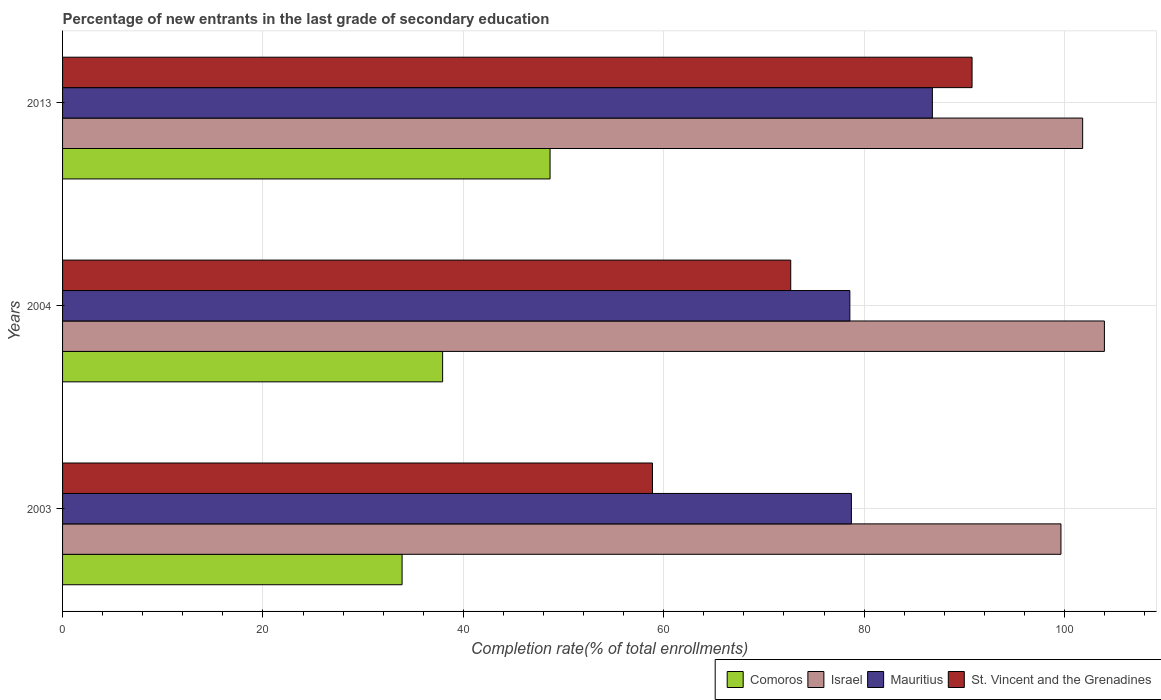Are the number of bars per tick equal to the number of legend labels?
Offer a terse response. Yes. What is the percentage of new entrants in Mauritius in 2003?
Ensure brevity in your answer.  78.73. Across all years, what is the maximum percentage of new entrants in Mauritius?
Offer a terse response. 86.81. Across all years, what is the minimum percentage of new entrants in Mauritius?
Offer a terse response. 78.57. In which year was the percentage of new entrants in St. Vincent and the Grenadines minimum?
Keep it short and to the point. 2003. What is the total percentage of new entrants in Israel in the graph?
Give a very brief answer. 305.43. What is the difference between the percentage of new entrants in Mauritius in 2004 and that in 2013?
Your answer should be very brief. -8.24. What is the difference between the percentage of new entrants in Israel in 2004 and the percentage of new entrants in St. Vincent and the Grenadines in 2003?
Offer a very short reply. 45.1. What is the average percentage of new entrants in St. Vincent and the Grenadines per year?
Your answer should be very brief. 74.11. In the year 2003, what is the difference between the percentage of new entrants in St. Vincent and the Grenadines and percentage of new entrants in Mauritius?
Offer a very short reply. -19.85. What is the ratio of the percentage of new entrants in Mauritius in 2003 to that in 2013?
Give a very brief answer. 0.91. What is the difference between the highest and the second highest percentage of new entrants in Comoros?
Ensure brevity in your answer.  10.72. What is the difference between the highest and the lowest percentage of new entrants in St. Vincent and the Grenadines?
Offer a very short reply. 31.89. In how many years, is the percentage of new entrants in Comoros greater than the average percentage of new entrants in Comoros taken over all years?
Offer a terse response. 1. What does the 2nd bar from the top in 2004 represents?
Offer a terse response. Mauritius. What does the 4th bar from the bottom in 2004 represents?
Give a very brief answer. St. Vincent and the Grenadines. How many bars are there?
Offer a terse response. 12. What is the difference between two consecutive major ticks on the X-axis?
Offer a very short reply. 20. Are the values on the major ticks of X-axis written in scientific E-notation?
Your response must be concise. No. Does the graph contain grids?
Offer a very short reply. Yes. How many legend labels are there?
Keep it short and to the point. 4. What is the title of the graph?
Give a very brief answer. Percentage of new entrants in the last grade of secondary education. What is the label or title of the X-axis?
Offer a very short reply. Completion rate(% of total enrollments). What is the label or title of the Y-axis?
Give a very brief answer. Years. What is the Completion rate(% of total enrollments) in Comoros in 2003?
Make the answer very short. 33.89. What is the Completion rate(% of total enrollments) in Israel in 2003?
Your answer should be very brief. 99.64. What is the Completion rate(% of total enrollments) in Mauritius in 2003?
Provide a short and direct response. 78.73. What is the Completion rate(% of total enrollments) in St. Vincent and the Grenadines in 2003?
Provide a succinct answer. 58.88. What is the Completion rate(% of total enrollments) of Comoros in 2004?
Your answer should be very brief. 37.93. What is the Completion rate(% of total enrollments) in Israel in 2004?
Your answer should be very brief. 103.98. What is the Completion rate(% of total enrollments) of Mauritius in 2004?
Your answer should be very brief. 78.57. What is the Completion rate(% of total enrollments) of St. Vincent and the Grenadines in 2004?
Offer a terse response. 72.67. What is the Completion rate(% of total enrollments) in Comoros in 2013?
Your response must be concise. 48.65. What is the Completion rate(% of total enrollments) of Israel in 2013?
Give a very brief answer. 101.81. What is the Completion rate(% of total enrollments) of Mauritius in 2013?
Offer a terse response. 86.81. What is the Completion rate(% of total enrollments) in St. Vincent and the Grenadines in 2013?
Offer a very short reply. 90.77. Across all years, what is the maximum Completion rate(% of total enrollments) in Comoros?
Keep it short and to the point. 48.65. Across all years, what is the maximum Completion rate(% of total enrollments) in Israel?
Your response must be concise. 103.98. Across all years, what is the maximum Completion rate(% of total enrollments) in Mauritius?
Give a very brief answer. 86.81. Across all years, what is the maximum Completion rate(% of total enrollments) in St. Vincent and the Grenadines?
Your answer should be compact. 90.77. Across all years, what is the minimum Completion rate(% of total enrollments) in Comoros?
Provide a succinct answer. 33.89. Across all years, what is the minimum Completion rate(% of total enrollments) of Israel?
Offer a terse response. 99.64. Across all years, what is the minimum Completion rate(% of total enrollments) in Mauritius?
Your response must be concise. 78.57. Across all years, what is the minimum Completion rate(% of total enrollments) of St. Vincent and the Grenadines?
Provide a short and direct response. 58.88. What is the total Completion rate(% of total enrollments) in Comoros in the graph?
Ensure brevity in your answer.  120.47. What is the total Completion rate(% of total enrollments) of Israel in the graph?
Your answer should be compact. 305.43. What is the total Completion rate(% of total enrollments) in Mauritius in the graph?
Give a very brief answer. 244.11. What is the total Completion rate(% of total enrollments) of St. Vincent and the Grenadines in the graph?
Make the answer very short. 222.32. What is the difference between the Completion rate(% of total enrollments) of Comoros in 2003 and that in 2004?
Keep it short and to the point. -4.05. What is the difference between the Completion rate(% of total enrollments) in Israel in 2003 and that in 2004?
Ensure brevity in your answer.  -4.34. What is the difference between the Completion rate(% of total enrollments) of Mauritius in 2003 and that in 2004?
Offer a terse response. 0.15. What is the difference between the Completion rate(% of total enrollments) of St. Vincent and the Grenadines in 2003 and that in 2004?
Make the answer very short. -13.8. What is the difference between the Completion rate(% of total enrollments) of Comoros in 2003 and that in 2013?
Offer a very short reply. -14.77. What is the difference between the Completion rate(% of total enrollments) of Israel in 2003 and that in 2013?
Make the answer very short. -2.17. What is the difference between the Completion rate(% of total enrollments) of Mauritius in 2003 and that in 2013?
Your answer should be compact. -8.08. What is the difference between the Completion rate(% of total enrollments) of St. Vincent and the Grenadines in 2003 and that in 2013?
Offer a terse response. -31.89. What is the difference between the Completion rate(% of total enrollments) of Comoros in 2004 and that in 2013?
Give a very brief answer. -10.72. What is the difference between the Completion rate(% of total enrollments) in Israel in 2004 and that in 2013?
Your response must be concise. 2.17. What is the difference between the Completion rate(% of total enrollments) in Mauritius in 2004 and that in 2013?
Offer a very short reply. -8.24. What is the difference between the Completion rate(% of total enrollments) in St. Vincent and the Grenadines in 2004 and that in 2013?
Keep it short and to the point. -18.1. What is the difference between the Completion rate(% of total enrollments) of Comoros in 2003 and the Completion rate(% of total enrollments) of Israel in 2004?
Your response must be concise. -70.09. What is the difference between the Completion rate(% of total enrollments) of Comoros in 2003 and the Completion rate(% of total enrollments) of Mauritius in 2004?
Your answer should be compact. -44.69. What is the difference between the Completion rate(% of total enrollments) of Comoros in 2003 and the Completion rate(% of total enrollments) of St. Vincent and the Grenadines in 2004?
Keep it short and to the point. -38.79. What is the difference between the Completion rate(% of total enrollments) in Israel in 2003 and the Completion rate(% of total enrollments) in Mauritius in 2004?
Offer a very short reply. 21.07. What is the difference between the Completion rate(% of total enrollments) in Israel in 2003 and the Completion rate(% of total enrollments) in St. Vincent and the Grenadines in 2004?
Your answer should be compact. 26.97. What is the difference between the Completion rate(% of total enrollments) in Mauritius in 2003 and the Completion rate(% of total enrollments) in St. Vincent and the Grenadines in 2004?
Give a very brief answer. 6.05. What is the difference between the Completion rate(% of total enrollments) in Comoros in 2003 and the Completion rate(% of total enrollments) in Israel in 2013?
Provide a succinct answer. -67.92. What is the difference between the Completion rate(% of total enrollments) in Comoros in 2003 and the Completion rate(% of total enrollments) in Mauritius in 2013?
Your answer should be very brief. -52.92. What is the difference between the Completion rate(% of total enrollments) of Comoros in 2003 and the Completion rate(% of total enrollments) of St. Vincent and the Grenadines in 2013?
Your response must be concise. -56.89. What is the difference between the Completion rate(% of total enrollments) in Israel in 2003 and the Completion rate(% of total enrollments) in Mauritius in 2013?
Make the answer very short. 12.83. What is the difference between the Completion rate(% of total enrollments) in Israel in 2003 and the Completion rate(% of total enrollments) in St. Vincent and the Grenadines in 2013?
Provide a succinct answer. 8.87. What is the difference between the Completion rate(% of total enrollments) in Mauritius in 2003 and the Completion rate(% of total enrollments) in St. Vincent and the Grenadines in 2013?
Give a very brief answer. -12.04. What is the difference between the Completion rate(% of total enrollments) of Comoros in 2004 and the Completion rate(% of total enrollments) of Israel in 2013?
Ensure brevity in your answer.  -63.88. What is the difference between the Completion rate(% of total enrollments) in Comoros in 2004 and the Completion rate(% of total enrollments) in Mauritius in 2013?
Make the answer very short. -48.88. What is the difference between the Completion rate(% of total enrollments) of Comoros in 2004 and the Completion rate(% of total enrollments) of St. Vincent and the Grenadines in 2013?
Keep it short and to the point. -52.84. What is the difference between the Completion rate(% of total enrollments) in Israel in 2004 and the Completion rate(% of total enrollments) in Mauritius in 2013?
Your answer should be very brief. 17.17. What is the difference between the Completion rate(% of total enrollments) in Israel in 2004 and the Completion rate(% of total enrollments) in St. Vincent and the Grenadines in 2013?
Ensure brevity in your answer.  13.21. What is the difference between the Completion rate(% of total enrollments) in Mauritius in 2004 and the Completion rate(% of total enrollments) in St. Vincent and the Grenadines in 2013?
Your answer should be compact. -12.2. What is the average Completion rate(% of total enrollments) of Comoros per year?
Provide a short and direct response. 40.16. What is the average Completion rate(% of total enrollments) in Israel per year?
Your response must be concise. 101.81. What is the average Completion rate(% of total enrollments) of Mauritius per year?
Make the answer very short. 81.37. What is the average Completion rate(% of total enrollments) in St. Vincent and the Grenadines per year?
Provide a short and direct response. 74.11. In the year 2003, what is the difference between the Completion rate(% of total enrollments) of Comoros and Completion rate(% of total enrollments) of Israel?
Give a very brief answer. -65.76. In the year 2003, what is the difference between the Completion rate(% of total enrollments) in Comoros and Completion rate(% of total enrollments) in Mauritius?
Your answer should be compact. -44.84. In the year 2003, what is the difference between the Completion rate(% of total enrollments) of Comoros and Completion rate(% of total enrollments) of St. Vincent and the Grenadines?
Your answer should be compact. -24.99. In the year 2003, what is the difference between the Completion rate(% of total enrollments) in Israel and Completion rate(% of total enrollments) in Mauritius?
Offer a terse response. 20.91. In the year 2003, what is the difference between the Completion rate(% of total enrollments) of Israel and Completion rate(% of total enrollments) of St. Vincent and the Grenadines?
Provide a succinct answer. 40.77. In the year 2003, what is the difference between the Completion rate(% of total enrollments) of Mauritius and Completion rate(% of total enrollments) of St. Vincent and the Grenadines?
Provide a succinct answer. 19.85. In the year 2004, what is the difference between the Completion rate(% of total enrollments) in Comoros and Completion rate(% of total enrollments) in Israel?
Make the answer very short. -66.05. In the year 2004, what is the difference between the Completion rate(% of total enrollments) of Comoros and Completion rate(% of total enrollments) of Mauritius?
Offer a terse response. -40.64. In the year 2004, what is the difference between the Completion rate(% of total enrollments) in Comoros and Completion rate(% of total enrollments) in St. Vincent and the Grenadines?
Offer a terse response. -34.74. In the year 2004, what is the difference between the Completion rate(% of total enrollments) of Israel and Completion rate(% of total enrollments) of Mauritius?
Provide a succinct answer. 25.4. In the year 2004, what is the difference between the Completion rate(% of total enrollments) of Israel and Completion rate(% of total enrollments) of St. Vincent and the Grenadines?
Provide a succinct answer. 31.3. In the year 2004, what is the difference between the Completion rate(% of total enrollments) in Mauritius and Completion rate(% of total enrollments) in St. Vincent and the Grenadines?
Provide a succinct answer. 5.9. In the year 2013, what is the difference between the Completion rate(% of total enrollments) in Comoros and Completion rate(% of total enrollments) in Israel?
Provide a succinct answer. -53.15. In the year 2013, what is the difference between the Completion rate(% of total enrollments) of Comoros and Completion rate(% of total enrollments) of Mauritius?
Give a very brief answer. -38.15. In the year 2013, what is the difference between the Completion rate(% of total enrollments) in Comoros and Completion rate(% of total enrollments) in St. Vincent and the Grenadines?
Offer a very short reply. -42.12. In the year 2013, what is the difference between the Completion rate(% of total enrollments) in Israel and Completion rate(% of total enrollments) in Mauritius?
Give a very brief answer. 15. In the year 2013, what is the difference between the Completion rate(% of total enrollments) in Israel and Completion rate(% of total enrollments) in St. Vincent and the Grenadines?
Ensure brevity in your answer.  11.04. In the year 2013, what is the difference between the Completion rate(% of total enrollments) in Mauritius and Completion rate(% of total enrollments) in St. Vincent and the Grenadines?
Offer a terse response. -3.96. What is the ratio of the Completion rate(% of total enrollments) of Comoros in 2003 to that in 2004?
Your response must be concise. 0.89. What is the ratio of the Completion rate(% of total enrollments) of Israel in 2003 to that in 2004?
Your answer should be very brief. 0.96. What is the ratio of the Completion rate(% of total enrollments) of Mauritius in 2003 to that in 2004?
Provide a short and direct response. 1. What is the ratio of the Completion rate(% of total enrollments) of St. Vincent and the Grenadines in 2003 to that in 2004?
Your answer should be very brief. 0.81. What is the ratio of the Completion rate(% of total enrollments) in Comoros in 2003 to that in 2013?
Your answer should be very brief. 0.7. What is the ratio of the Completion rate(% of total enrollments) of Israel in 2003 to that in 2013?
Keep it short and to the point. 0.98. What is the ratio of the Completion rate(% of total enrollments) in Mauritius in 2003 to that in 2013?
Offer a terse response. 0.91. What is the ratio of the Completion rate(% of total enrollments) of St. Vincent and the Grenadines in 2003 to that in 2013?
Ensure brevity in your answer.  0.65. What is the ratio of the Completion rate(% of total enrollments) in Comoros in 2004 to that in 2013?
Provide a succinct answer. 0.78. What is the ratio of the Completion rate(% of total enrollments) of Israel in 2004 to that in 2013?
Your answer should be very brief. 1.02. What is the ratio of the Completion rate(% of total enrollments) in Mauritius in 2004 to that in 2013?
Make the answer very short. 0.91. What is the ratio of the Completion rate(% of total enrollments) of St. Vincent and the Grenadines in 2004 to that in 2013?
Offer a very short reply. 0.8. What is the difference between the highest and the second highest Completion rate(% of total enrollments) of Comoros?
Your answer should be compact. 10.72. What is the difference between the highest and the second highest Completion rate(% of total enrollments) in Israel?
Give a very brief answer. 2.17. What is the difference between the highest and the second highest Completion rate(% of total enrollments) of Mauritius?
Make the answer very short. 8.08. What is the difference between the highest and the second highest Completion rate(% of total enrollments) in St. Vincent and the Grenadines?
Give a very brief answer. 18.1. What is the difference between the highest and the lowest Completion rate(% of total enrollments) in Comoros?
Keep it short and to the point. 14.77. What is the difference between the highest and the lowest Completion rate(% of total enrollments) in Israel?
Provide a short and direct response. 4.34. What is the difference between the highest and the lowest Completion rate(% of total enrollments) in Mauritius?
Offer a very short reply. 8.24. What is the difference between the highest and the lowest Completion rate(% of total enrollments) of St. Vincent and the Grenadines?
Ensure brevity in your answer.  31.89. 